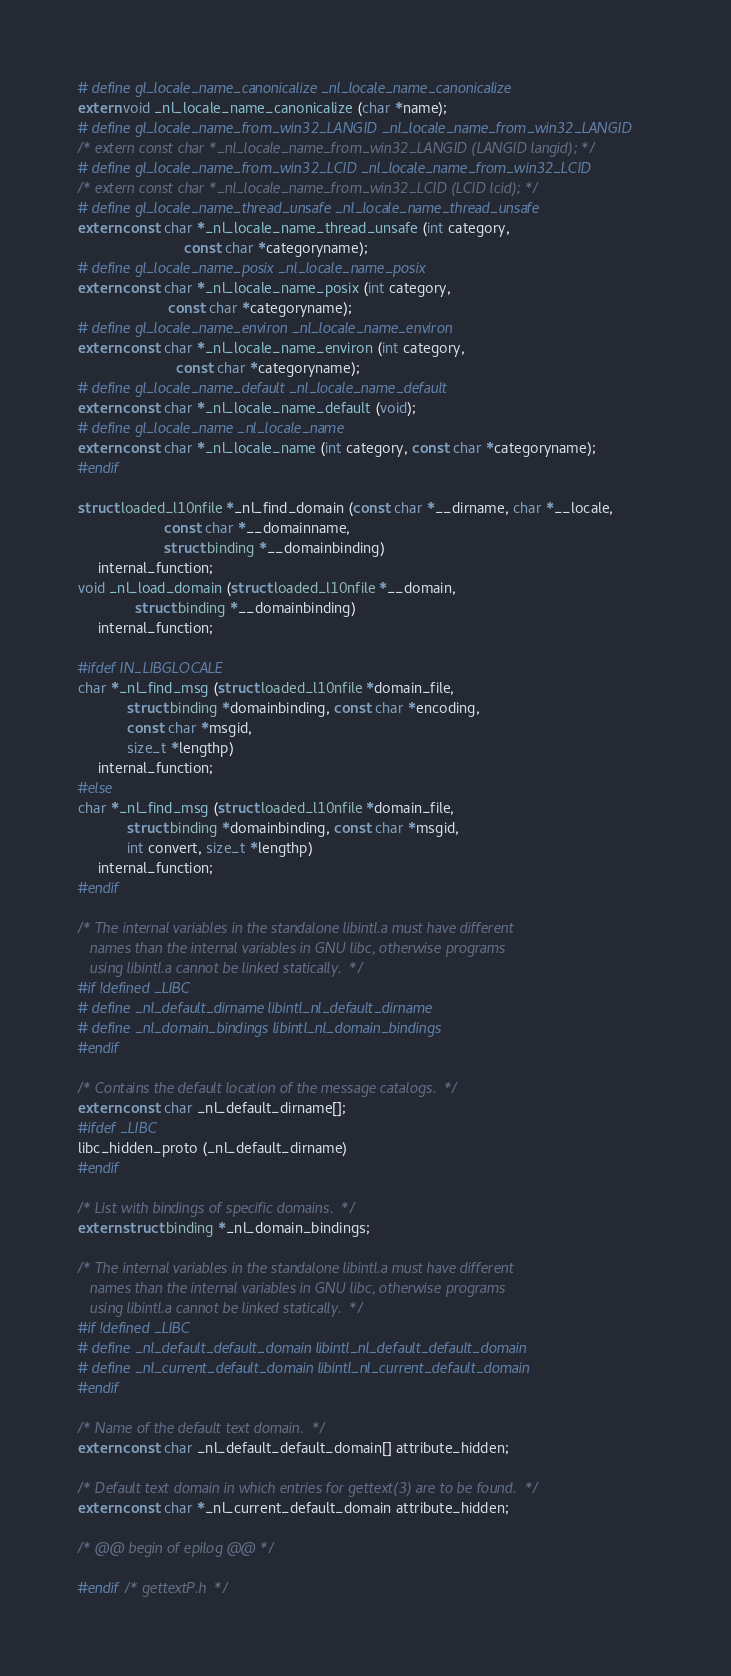Convert code to text. <code><loc_0><loc_0><loc_500><loc_500><_C_># define gl_locale_name_canonicalize _nl_locale_name_canonicalize
extern void _nl_locale_name_canonicalize (char *name);
# define gl_locale_name_from_win32_LANGID _nl_locale_name_from_win32_LANGID
/* extern const char *_nl_locale_name_from_win32_LANGID (LANGID langid); */
# define gl_locale_name_from_win32_LCID _nl_locale_name_from_win32_LCID
/* extern const char *_nl_locale_name_from_win32_LCID (LCID lcid); */
# define gl_locale_name_thread_unsafe _nl_locale_name_thread_unsafe
extern const char *_nl_locale_name_thread_unsafe (int category,
						  const char *categoryname);
# define gl_locale_name_posix _nl_locale_name_posix
extern const char *_nl_locale_name_posix (int category,
					  const char *categoryname);
# define gl_locale_name_environ _nl_locale_name_environ
extern const char *_nl_locale_name_environ (int category,
					    const char *categoryname);
# define gl_locale_name_default _nl_locale_name_default
extern const char *_nl_locale_name_default (void);
# define gl_locale_name _nl_locale_name
extern const char *_nl_locale_name (int category, const char *categoryname);
#endif

struct loaded_l10nfile *_nl_find_domain (const char *__dirname, char *__locale,
					 const char *__domainname,
					 struct binding *__domainbinding)
     internal_function;
void _nl_load_domain (struct loaded_l10nfile *__domain,
		      struct binding *__domainbinding)
     internal_function;

#ifdef IN_LIBGLOCALE
char *_nl_find_msg (struct loaded_l10nfile *domain_file,
		    struct binding *domainbinding, const char *encoding,
		    const char *msgid,
		    size_t *lengthp)
     internal_function;
#else
char *_nl_find_msg (struct loaded_l10nfile *domain_file,
		    struct binding *domainbinding, const char *msgid,
		    int convert, size_t *lengthp)
     internal_function;
#endif

/* The internal variables in the standalone libintl.a must have different
   names than the internal variables in GNU libc, otherwise programs
   using libintl.a cannot be linked statically.  */
#if !defined _LIBC
# define _nl_default_dirname libintl_nl_default_dirname
# define _nl_domain_bindings libintl_nl_domain_bindings
#endif

/* Contains the default location of the message catalogs.  */
extern const char _nl_default_dirname[];
#ifdef _LIBC
libc_hidden_proto (_nl_default_dirname)
#endif

/* List with bindings of specific domains.  */
extern struct binding *_nl_domain_bindings;

/* The internal variables in the standalone libintl.a must have different
   names than the internal variables in GNU libc, otherwise programs
   using libintl.a cannot be linked statically.  */
#if !defined _LIBC
# define _nl_default_default_domain libintl_nl_default_default_domain
# define _nl_current_default_domain libintl_nl_current_default_domain
#endif

/* Name of the default text domain.  */
extern const char _nl_default_default_domain[] attribute_hidden;

/* Default text domain in which entries for gettext(3) are to be found.  */
extern const char *_nl_current_default_domain attribute_hidden;

/* @@ begin of epilog @@ */

#endif /* gettextP.h  */
</code> 